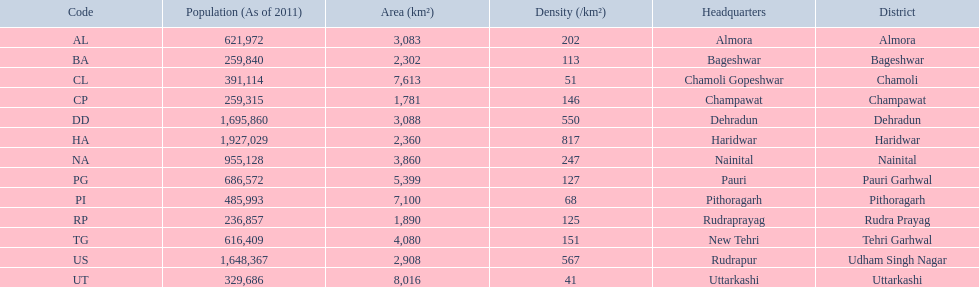What are the values for density of the districts of uttrakhand? 202, 113, 51, 146, 550, 817, 247, 127, 68, 125, 151, 567, 41. Which district has value of 51? Chamoli. 